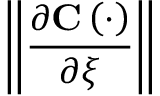<formula> <loc_0><loc_0><loc_500><loc_500>\left \| \frac { \partial C \left ( \cdot \right ) } { \partial \xi } \right \|</formula> 